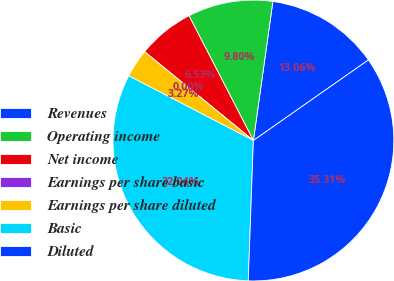<chart> <loc_0><loc_0><loc_500><loc_500><pie_chart><fcel>Revenues<fcel>Operating income<fcel>Net income<fcel>Earnings per share basic<fcel>Earnings per share diluted<fcel>Basic<fcel>Diluted<nl><fcel>13.06%<fcel>9.8%<fcel>6.53%<fcel>0.0%<fcel>3.27%<fcel>32.04%<fcel>35.31%<nl></chart> 